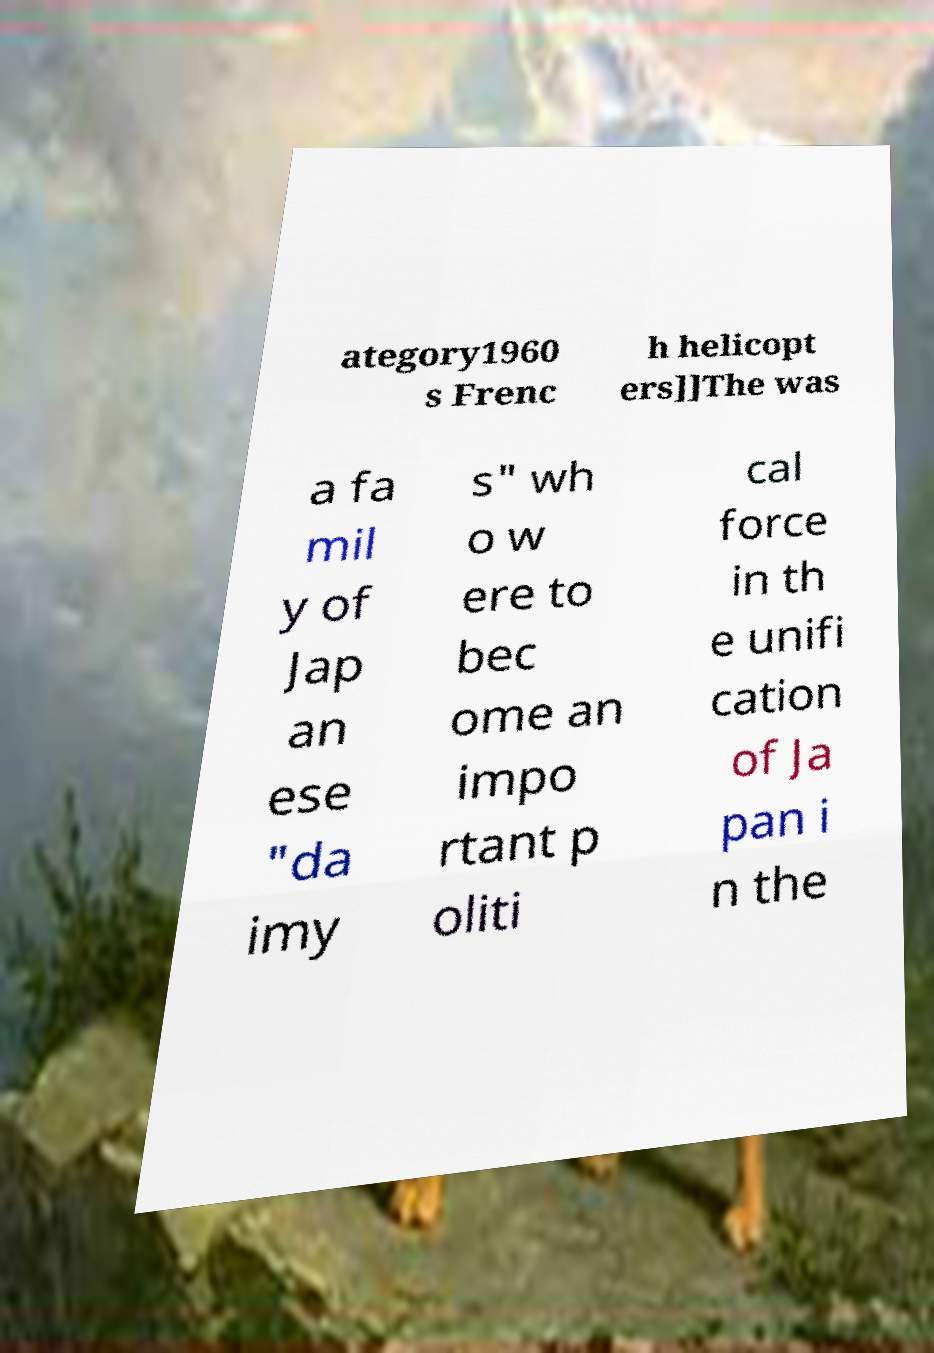Could you extract and type out the text from this image? ategory1960 s Frenc h helicopt ers]]The was a fa mil y of Jap an ese "da imy s" wh o w ere to bec ome an impo rtant p oliti cal force in th e unifi cation of Ja pan i n the 